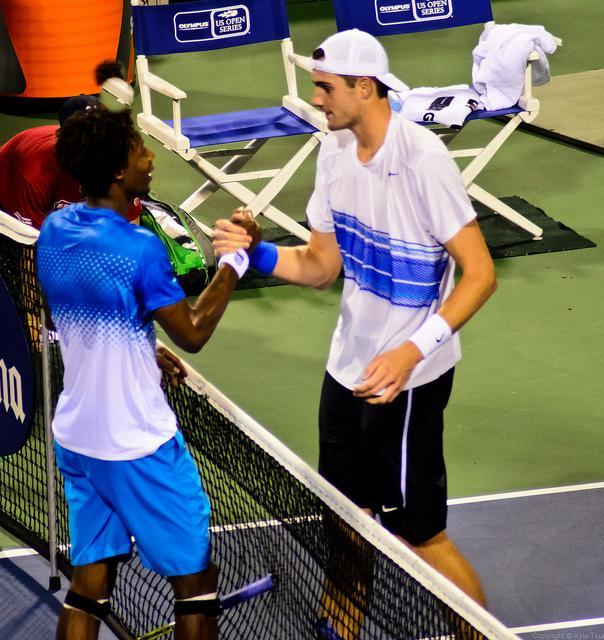Why have the two men gripped hands? sportsmanship 